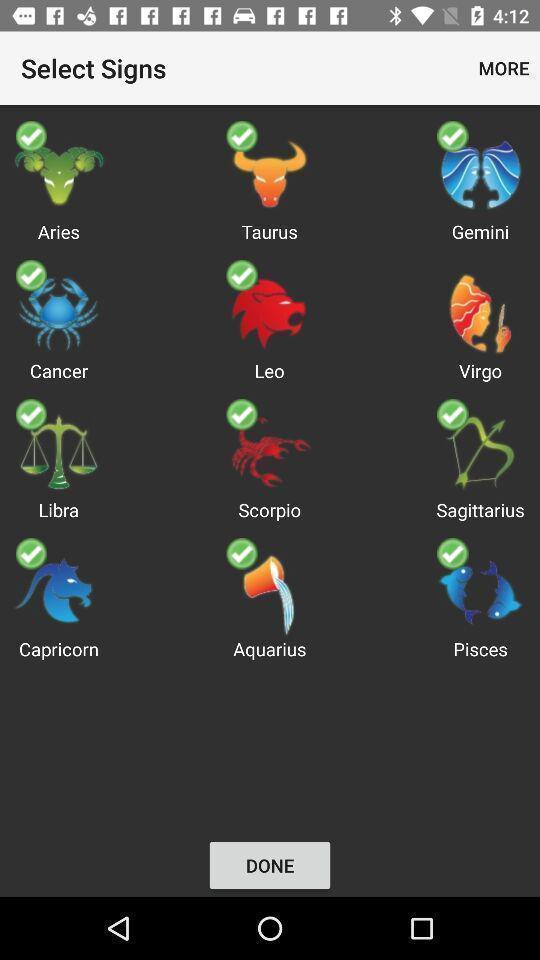Give me a narrative description of this picture. Screen showing signs to select. 